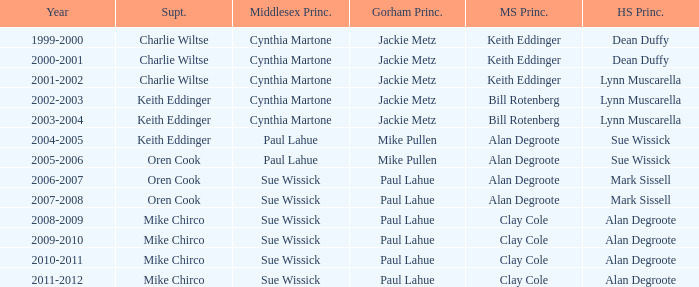How many middlesex principals were there in 2000-2001? 1.0. 